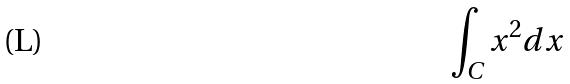<formula> <loc_0><loc_0><loc_500><loc_500>\int _ { C } x ^ { 2 } d x</formula> 